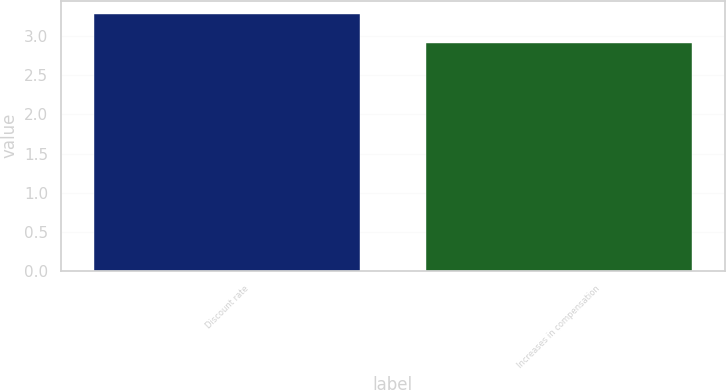Convert chart. <chart><loc_0><loc_0><loc_500><loc_500><bar_chart><fcel>Discount rate<fcel>Increases in compensation<nl><fcel>3.29<fcel>2.91<nl></chart> 